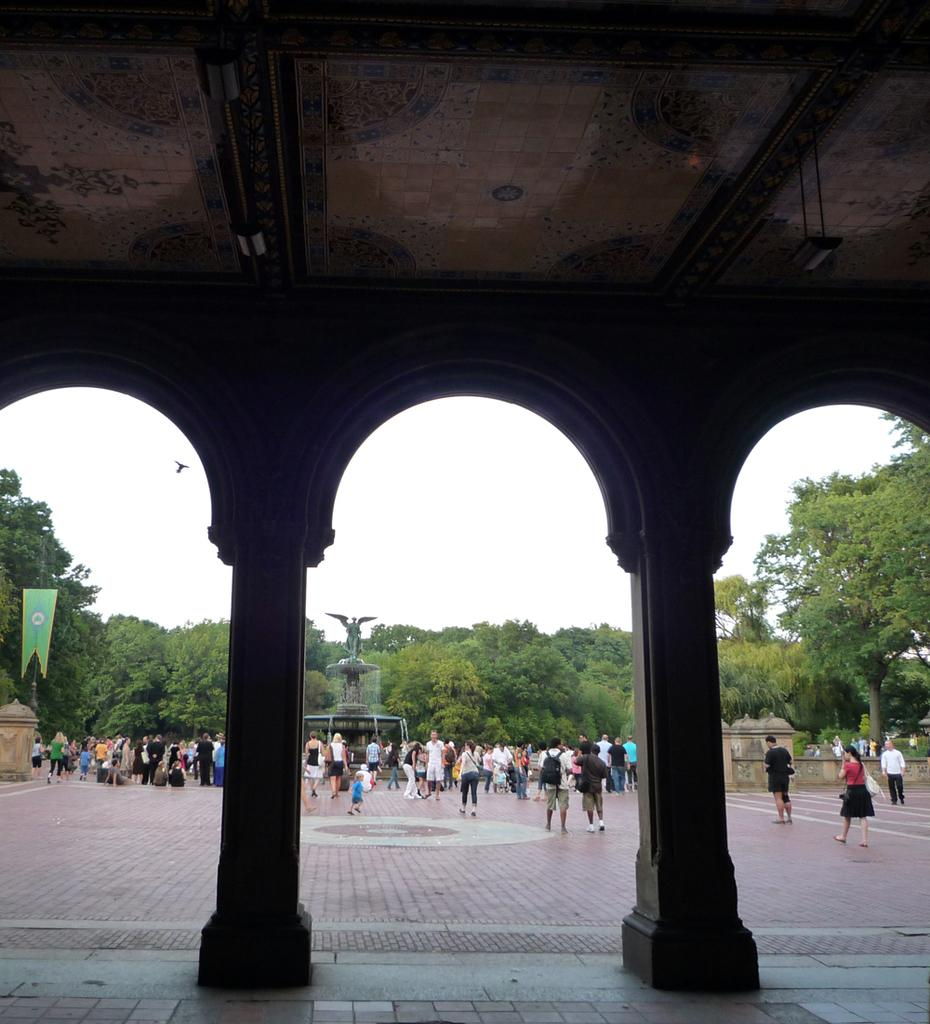How many people are in the image? There is a group of people in the image. What are the people in the image doing? The people are walking on the ground. What architectural features can be seen in the image? There are pillars in the image. What type of vegetation is present in the image? There are trees in the image. What is the symbolic object visible in the image? There is a flag in the image. What is visible in the background of the image? The sky is visible in the background of the image. What type of basin can be seen in the image? There is no basin present in the image. What type of crops is the farmer tending to in the image? There is no farmer or crops present in the image. 